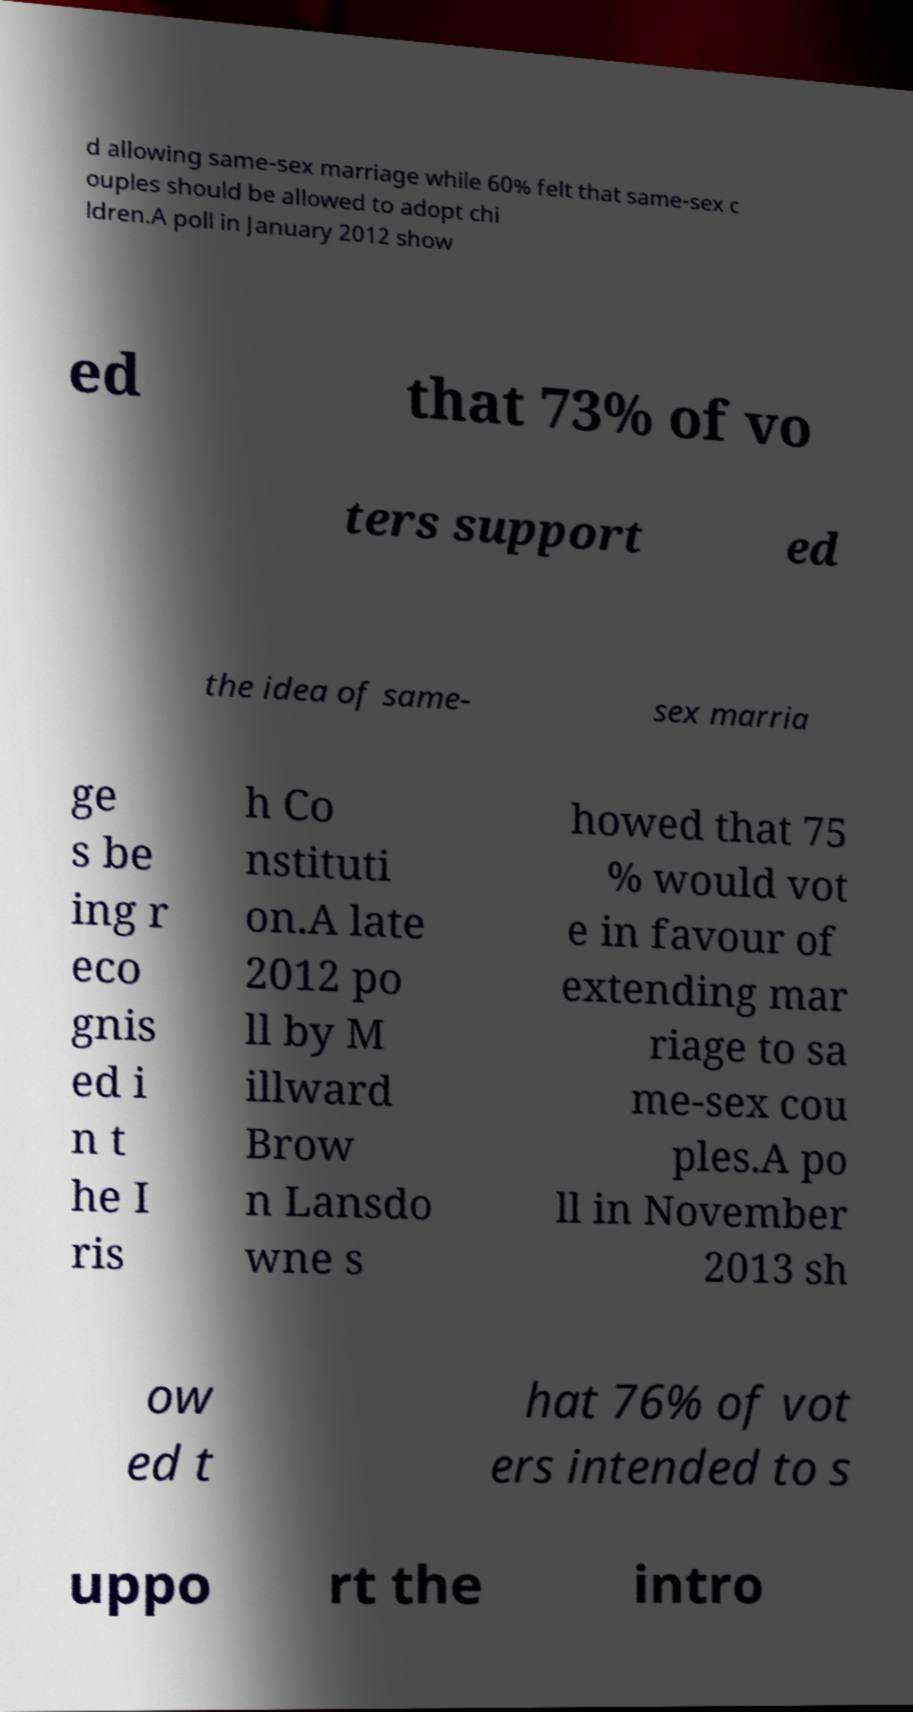There's text embedded in this image that I need extracted. Can you transcribe it verbatim? d allowing same-sex marriage while 60% felt that same-sex c ouples should be allowed to adopt chi ldren.A poll in January 2012 show ed that 73% of vo ters support ed the idea of same- sex marria ge s be ing r eco gnis ed i n t he I ris h Co nstituti on.A late 2012 po ll by M illward Brow n Lansdo wne s howed that 75 % would vot e in favour of extending mar riage to sa me-sex cou ples.A po ll in November 2013 sh ow ed t hat 76% of vot ers intended to s uppo rt the intro 